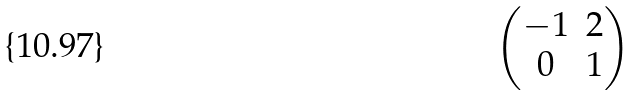<formula> <loc_0><loc_0><loc_500><loc_500>\begin{pmatrix} - 1 & 2 \\ 0 & 1 \end{pmatrix}</formula> 